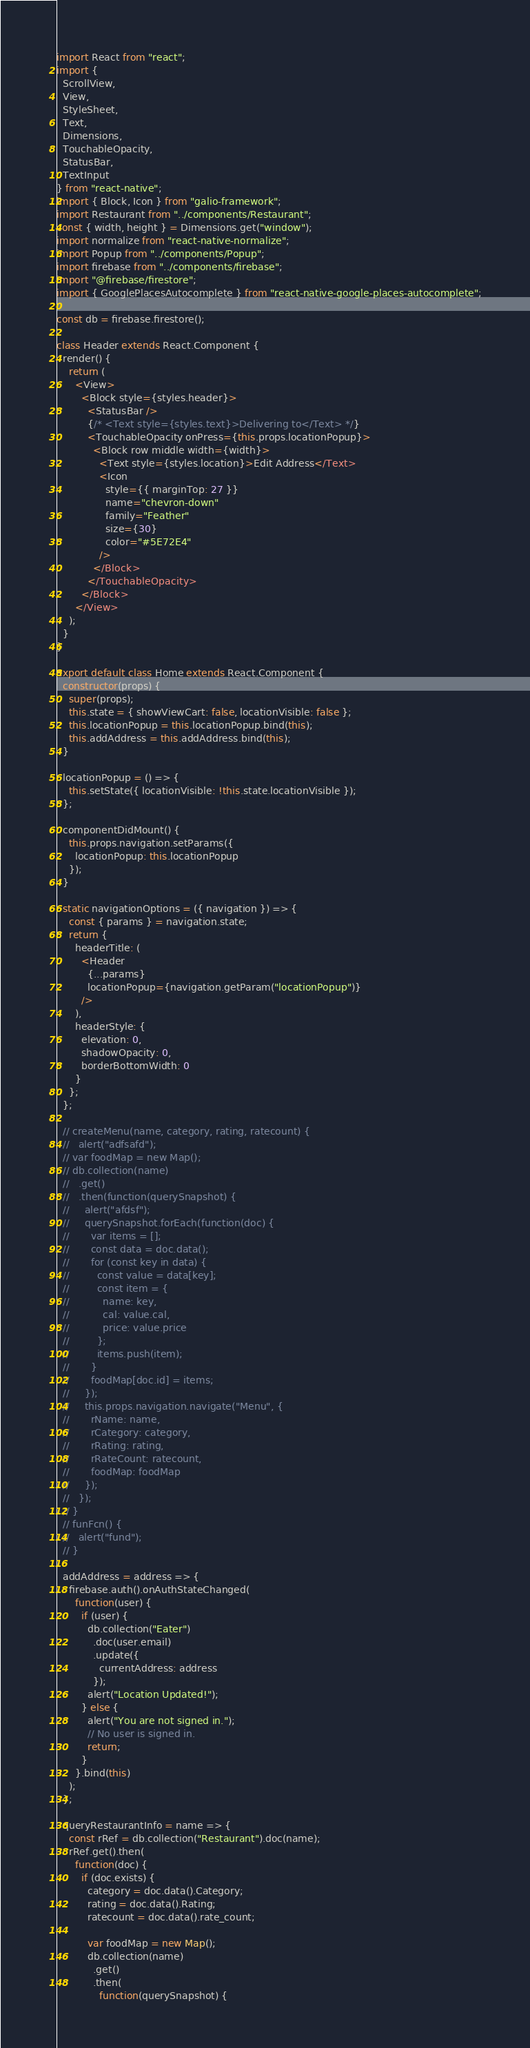<code> <loc_0><loc_0><loc_500><loc_500><_JavaScript_>import React from "react";
import {
  ScrollView,
  View,
  StyleSheet,
  Text,
  Dimensions,
  TouchableOpacity,
  StatusBar,
  TextInput
} from "react-native";
import { Block, Icon } from "galio-framework";
import Restaurant from "../components/Restaurant";
const { width, height } = Dimensions.get("window");
import normalize from "react-native-normalize";
import Popup from "../components/Popup";
import firebase from "../components/firebase";
import "@firebase/firestore";
import { GooglePlacesAutocomplete } from "react-native-google-places-autocomplete";

const db = firebase.firestore();

class Header extends React.Component {
  render() {
    return (
      <View>
        <Block style={styles.header}>
          <StatusBar />
          {/* <Text style={styles.text}>Delivering to</Text> */}
          <TouchableOpacity onPress={this.props.locationPopup}>
            <Block row middle width={width}>
              <Text style={styles.location}>Edit Address</Text>
              <Icon
                style={{ marginTop: 27 }}
                name="chevron-down"
                family="Feather"
                size={30}
                color="#5E72E4"
              />
            </Block>
          </TouchableOpacity>
        </Block>
      </View>
    );
  }
}

export default class Home extends React.Component {
  constructor(props) {
    super(props);
    this.state = { showViewCart: false, locationVisible: false };
    this.locationPopup = this.locationPopup.bind(this);
    this.addAddress = this.addAddress.bind(this);
  }

  locationPopup = () => {
    this.setState({ locationVisible: !this.state.locationVisible });
  };

  componentDidMount() {
    this.props.navigation.setParams({
      locationPopup: this.locationPopup
    });
  }

  static navigationOptions = ({ navigation }) => {
    const { params } = navigation.state;
    return {
      headerTitle: (
        <Header
          {...params}
          locationPopup={navigation.getParam("locationPopup")}
        />
      ),
      headerStyle: {
        elevation: 0,
        shadowOpacity: 0,
        borderBottomWidth: 0
      }
    };
  };

  // createMenu(name, category, rating, ratecount) {
  //   alert("adfsafd");
  // var foodMap = new Map();
  // db.collection(name)
  //   .get()
  //   .then(function(querySnapshot) {
  //     alert("afdsf");
  //     querySnapshot.forEach(function(doc) {
  //       var items = [];
  //       const data = doc.data();
  //       for (const key in data) {
  //         const value = data[key];
  //         const item = {
  //           name: key,
  //           cal: value.cal,
  //           price: value.price
  //         };
  //         items.push(item);
  //       }
  //       foodMap[doc.id] = items;
  //     });
  //     this.props.navigation.navigate("Menu", {
  //       rName: name,
  //       rCategory: category,
  //       rRating: rating,
  //       rRateCount: ratecount,
  //       foodMap: foodMap
  //     });
  //   });
  // }
  // funFcn() {
  //   alert("fund");
  // }

  addAddress = address => {
    firebase.auth().onAuthStateChanged(
      function(user) {
        if (user) {
          db.collection("Eater")
            .doc(user.email)
            .update({
              currentAddress: address
            });
          alert("Location Updated!");
        } else {
          alert("You are not signed in.");
          // No user is signed in.
          return;
        }
      }.bind(this)
    );
  };

  queryRestaurantInfo = name => {
    const rRef = db.collection("Restaurant").doc(name);
    rRef.get().then(
      function(doc) {
        if (doc.exists) {
          category = doc.data().Category;
          rating = doc.data().Rating;
          ratecount = doc.data().rate_count;

          var foodMap = new Map();
          db.collection(name)
            .get()
            .then(
              function(querySnapshot) {</code> 